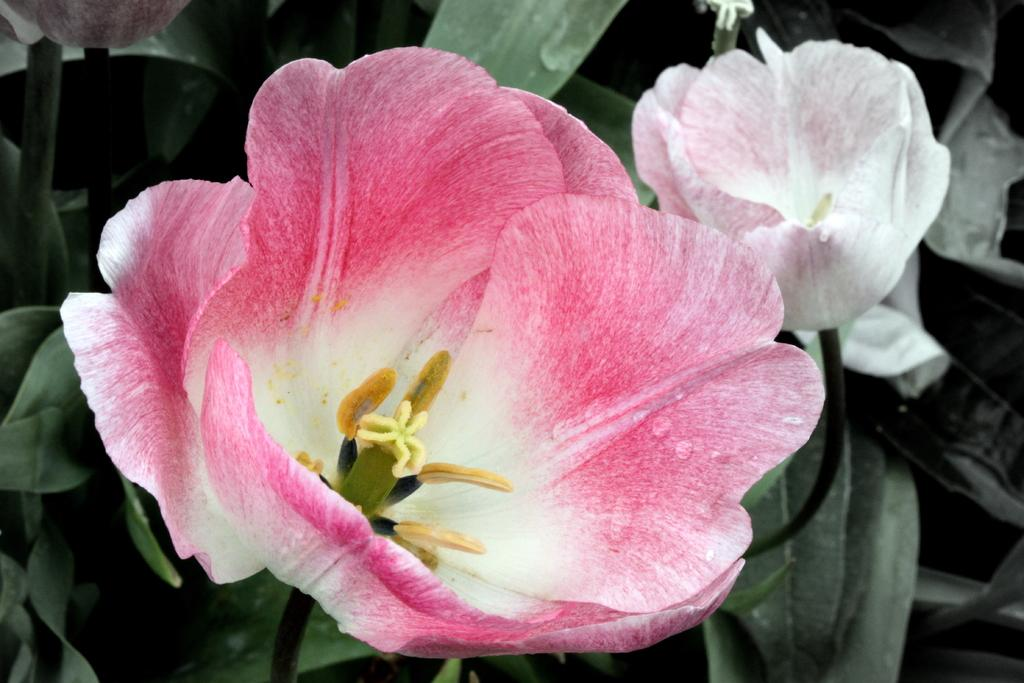What types of flora can be seen in the image? There are flowers and plants in the image. Can you describe the colors of the flowers in the image? One flower is pink and white in color, and another flower is white in color. What type of fruit is hanging from the sail in the image? There is no sail or fruit present in the image; it features flowers and plants. 